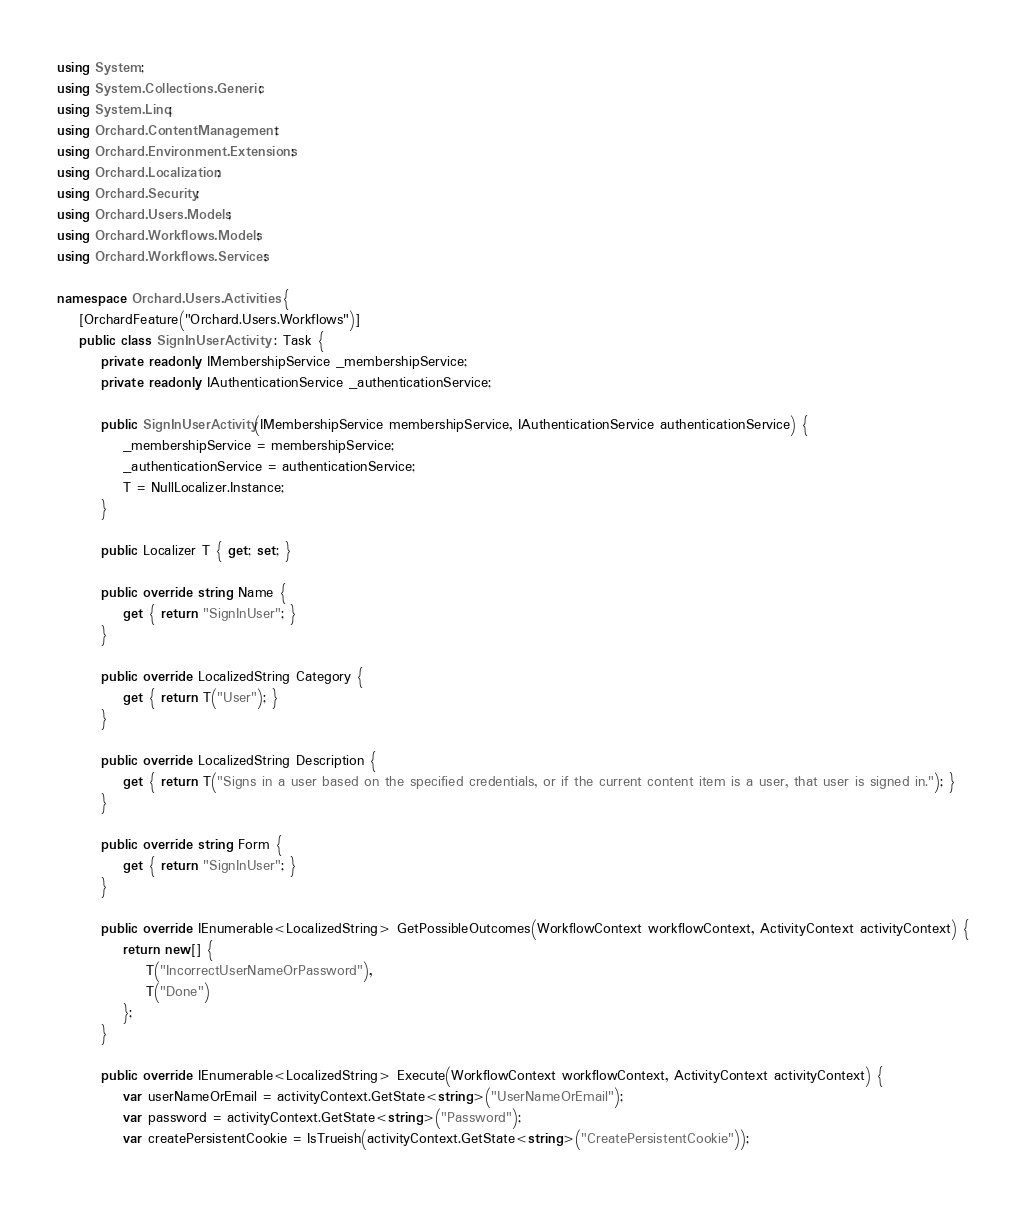Convert code to text. <code><loc_0><loc_0><loc_500><loc_500><_C#_>using System;
using System.Collections.Generic;
using System.Linq;
using Orchard.ContentManagement;
using Orchard.Environment.Extensions;
using Orchard.Localization;
using Orchard.Security;
using Orchard.Users.Models;
using Orchard.Workflows.Models;
using Orchard.Workflows.Services;

namespace Orchard.Users.Activities {
    [OrchardFeature("Orchard.Users.Workflows")]
    public class SignInUserActivity : Task {
        private readonly IMembershipService _membershipService;
        private readonly IAuthenticationService _authenticationService;

        public SignInUserActivity(IMembershipService membershipService, IAuthenticationService authenticationService) {
            _membershipService = membershipService;
            _authenticationService = authenticationService;
            T = NullLocalizer.Instance;
        }

        public Localizer T { get; set; }

        public override string Name {
            get { return "SignInUser"; }
        }

        public override LocalizedString Category {
            get { return T("User"); }
        }

        public override LocalizedString Description {
            get { return T("Signs in a user based on the specified credentials, or if the current content item is a user, that user is signed in."); }
        }

        public override string Form {
            get { return "SignInUser"; }
        }

        public override IEnumerable<LocalizedString> GetPossibleOutcomes(WorkflowContext workflowContext, ActivityContext activityContext) {
            return new[] {
                T("IncorrectUserNameOrPassword"),
                T("Done")
            };
        }

        public override IEnumerable<LocalizedString> Execute(WorkflowContext workflowContext, ActivityContext activityContext) {
            var userNameOrEmail = activityContext.GetState<string>("UserNameOrEmail");
            var password = activityContext.GetState<string>("Password");
            var createPersistentCookie = IsTrueish(activityContext.GetState<string>("CreatePersistentCookie"));</code> 